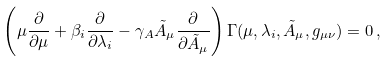<formula> <loc_0><loc_0><loc_500><loc_500>\left ( \mu \frac { \partial } { \partial \mu } + \beta _ { i } \frac { \partial } { \partial \lambda _ { i } } - \gamma _ { A } \tilde { A } _ { \mu } \frac { \partial } { \partial \tilde { A } _ { \mu } } \right ) \Gamma ( \mu , \lambda _ { i } , \tilde { A } _ { \mu } , g _ { \mu \nu } ) = 0 \, ,</formula> 